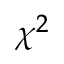<formula> <loc_0><loc_0><loc_500><loc_500>\chi ^ { 2 }</formula> 